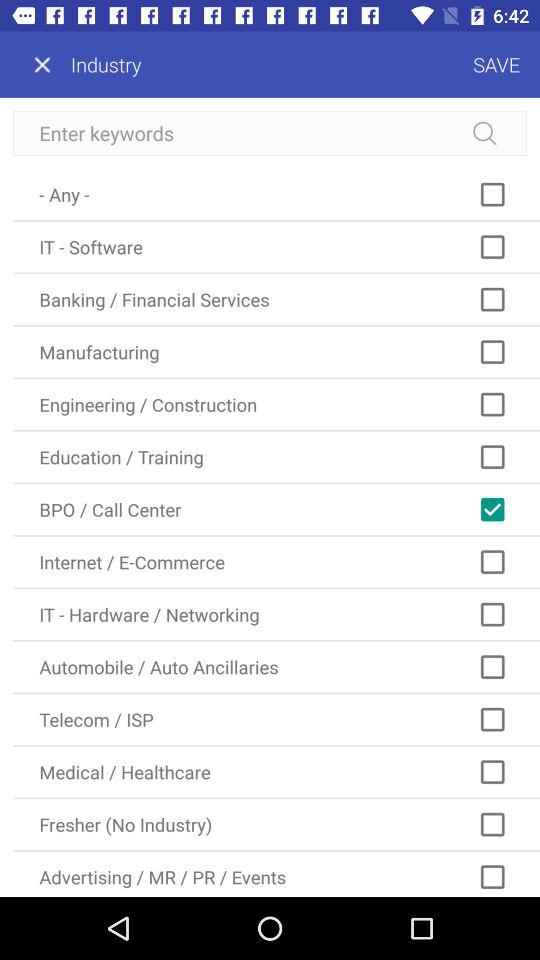What is the status of the "BPO / Call Center"? The status of the "BPO / Call Center" is "on". 